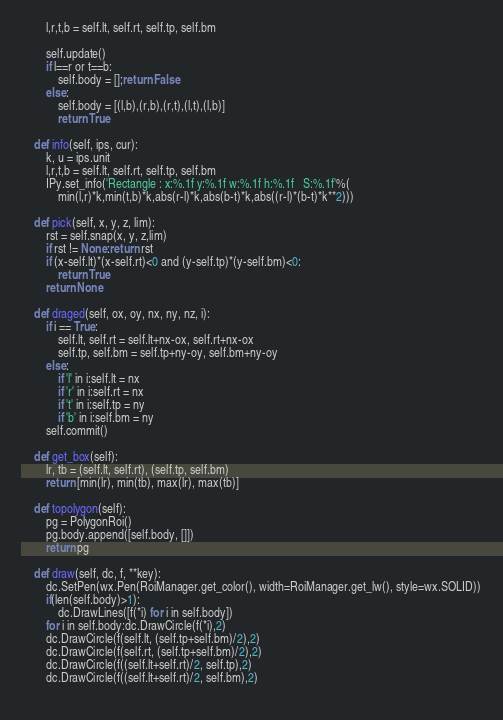Convert code to text. <code><loc_0><loc_0><loc_500><loc_500><_Python_>        l,r,t,b = self.lt, self.rt, self.tp, self.bm
        
        self.update()
        if l==r or t==b: 
            self.body = [];return False
        else: 
            self.body = [(l,b),(r,b),(r,t),(l,t),(l,b)]
            return True
        
    def info(self, ips, cur):
        k, u = ips.unit
        l,r,t,b = self.lt, self.rt, self.tp, self.bm
        IPy.set_info('Rectangle : x:%.1f y:%.1f w:%.1f h:%.1f   S:%.1f'%(
            min(l,r)*k,min(t,b)*k,abs(r-l)*k,abs(b-t)*k,abs((r-l)*(b-t)*k**2)))

    def pick(self, x, y, z, lim):
        rst = self.snap(x, y, z,lim)
        if rst != None:return rst
        if (x-self.lt)*(x-self.rt)<0 and (y-self.tp)*(y-self.bm)<0:
            return True
        return None

    def draged(self, ox, oy, nx, ny, nz, i):
        if i == True:
            self.lt, self.rt = self.lt+nx-ox, self.rt+nx-ox
            self.tp, self.bm = self.tp+ny-oy, self.bm+ny-oy
        else:
            if 'l' in i:self.lt = nx
            if 'r' in i:self.rt = nx
            if 't' in i:self.tp = ny
            if 'b' in i:self.bm = ny
        self.commit()
        
    def get_box(self):
        lr, tb = (self.lt, self.rt), (self.tp, self.bm)
        return [min(lr), min(tb), max(lr), max(tb)]
        
    def topolygon(self):
        pg = PolygonRoi()
        pg.body.append([self.body, []])
        return pg
        
    def draw(self, dc, f, **key):
        dc.SetPen(wx.Pen(RoiManager.get_color(), width=RoiManager.get_lw(), style=wx.SOLID))
        if(len(self.body)>1):
            dc.DrawLines([f(*i) for i in self.body])
        for i in self.body:dc.DrawCircle(f(*i),2)
        dc.DrawCircle(f(self.lt, (self.tp+self.bm)/2),2)
        dc.DrawCircle(f(self.rt, (self.tp+self.bm)/2),2)
        dc.DrawCircle(f((self.lt+self.rt)/2, self.tp),2)
        dc.DrawCircle(f((self.lt+self.rt)/2, self.bm),2)
        </code> 